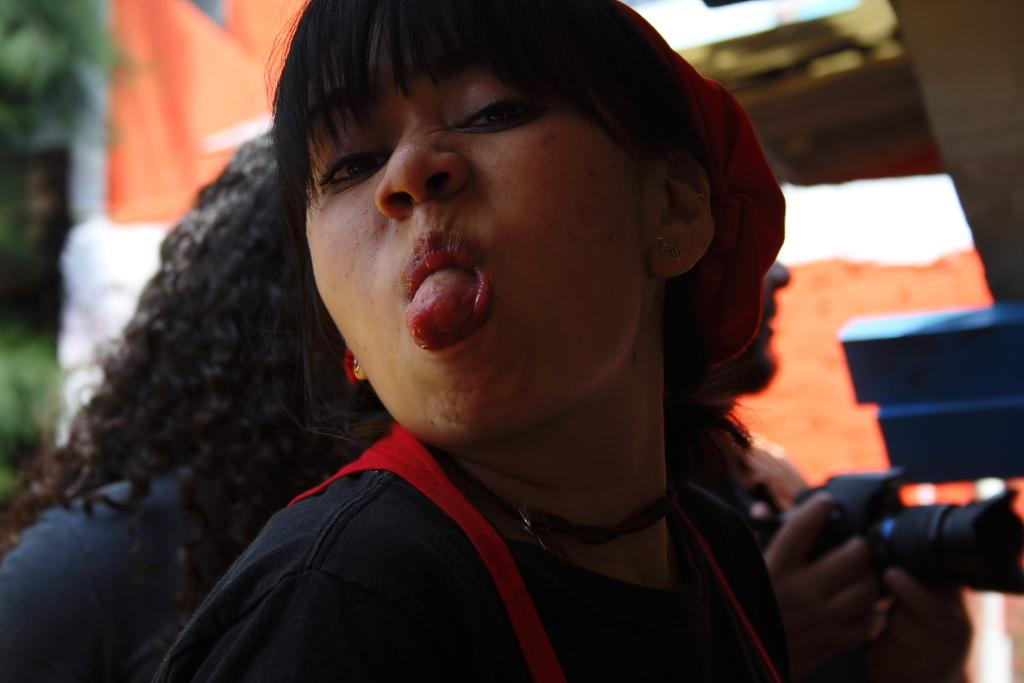How many people are present in the image? There are three people standing in the image. What is one of the people doing in the image? One person is holding a camera in the image. Can you describe the background of the image? There are blurred objects in the background of the image. What type of debt is being discussed by the people in the image? There is no indication of a debt being discussed in the image; the focus is on the people and the camera. 